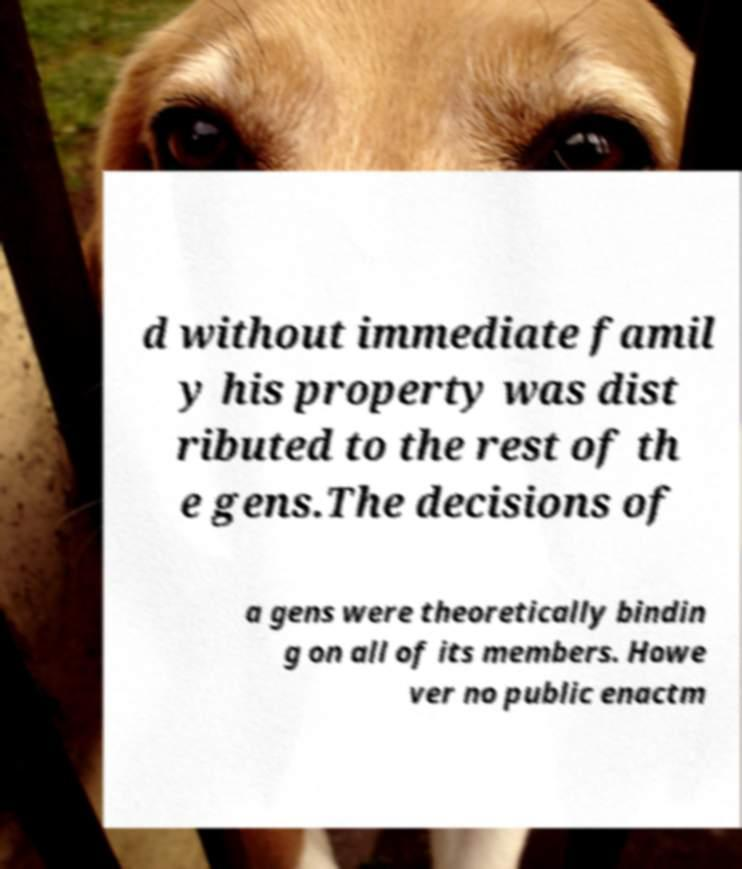I need the written content from this picture converted into text. Can you do that? d without immediate famil y his property was dist ributed to the rest of th e gens.The decisions of a gens were theoretically bindin g on all of its members. Howe ver no public enactm 